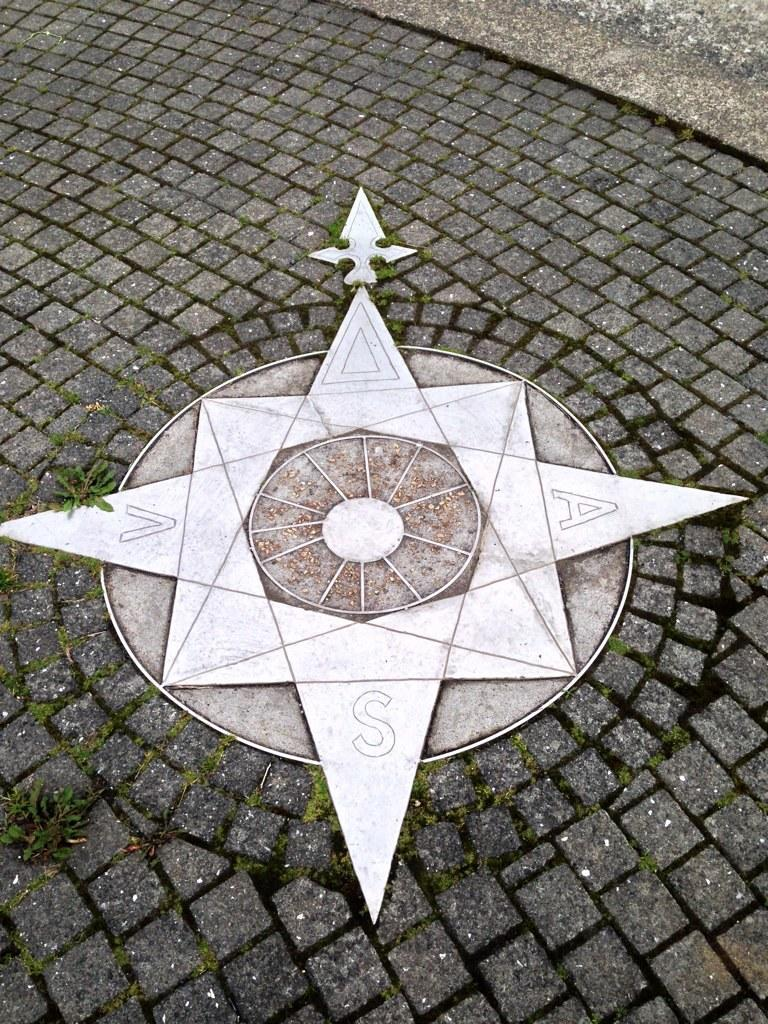What is the main object on the ground in the image? There is an object on the ground in the image, and it is white in color. What else can be seen in the image besides the white object? There are small plants in the image, and they are green in color. What type of trains can be seen in the image? There are no trains present in the image. What action are the plants performing in the image? Plants do not perform actions like humans do; they grow and photosynthesize. 